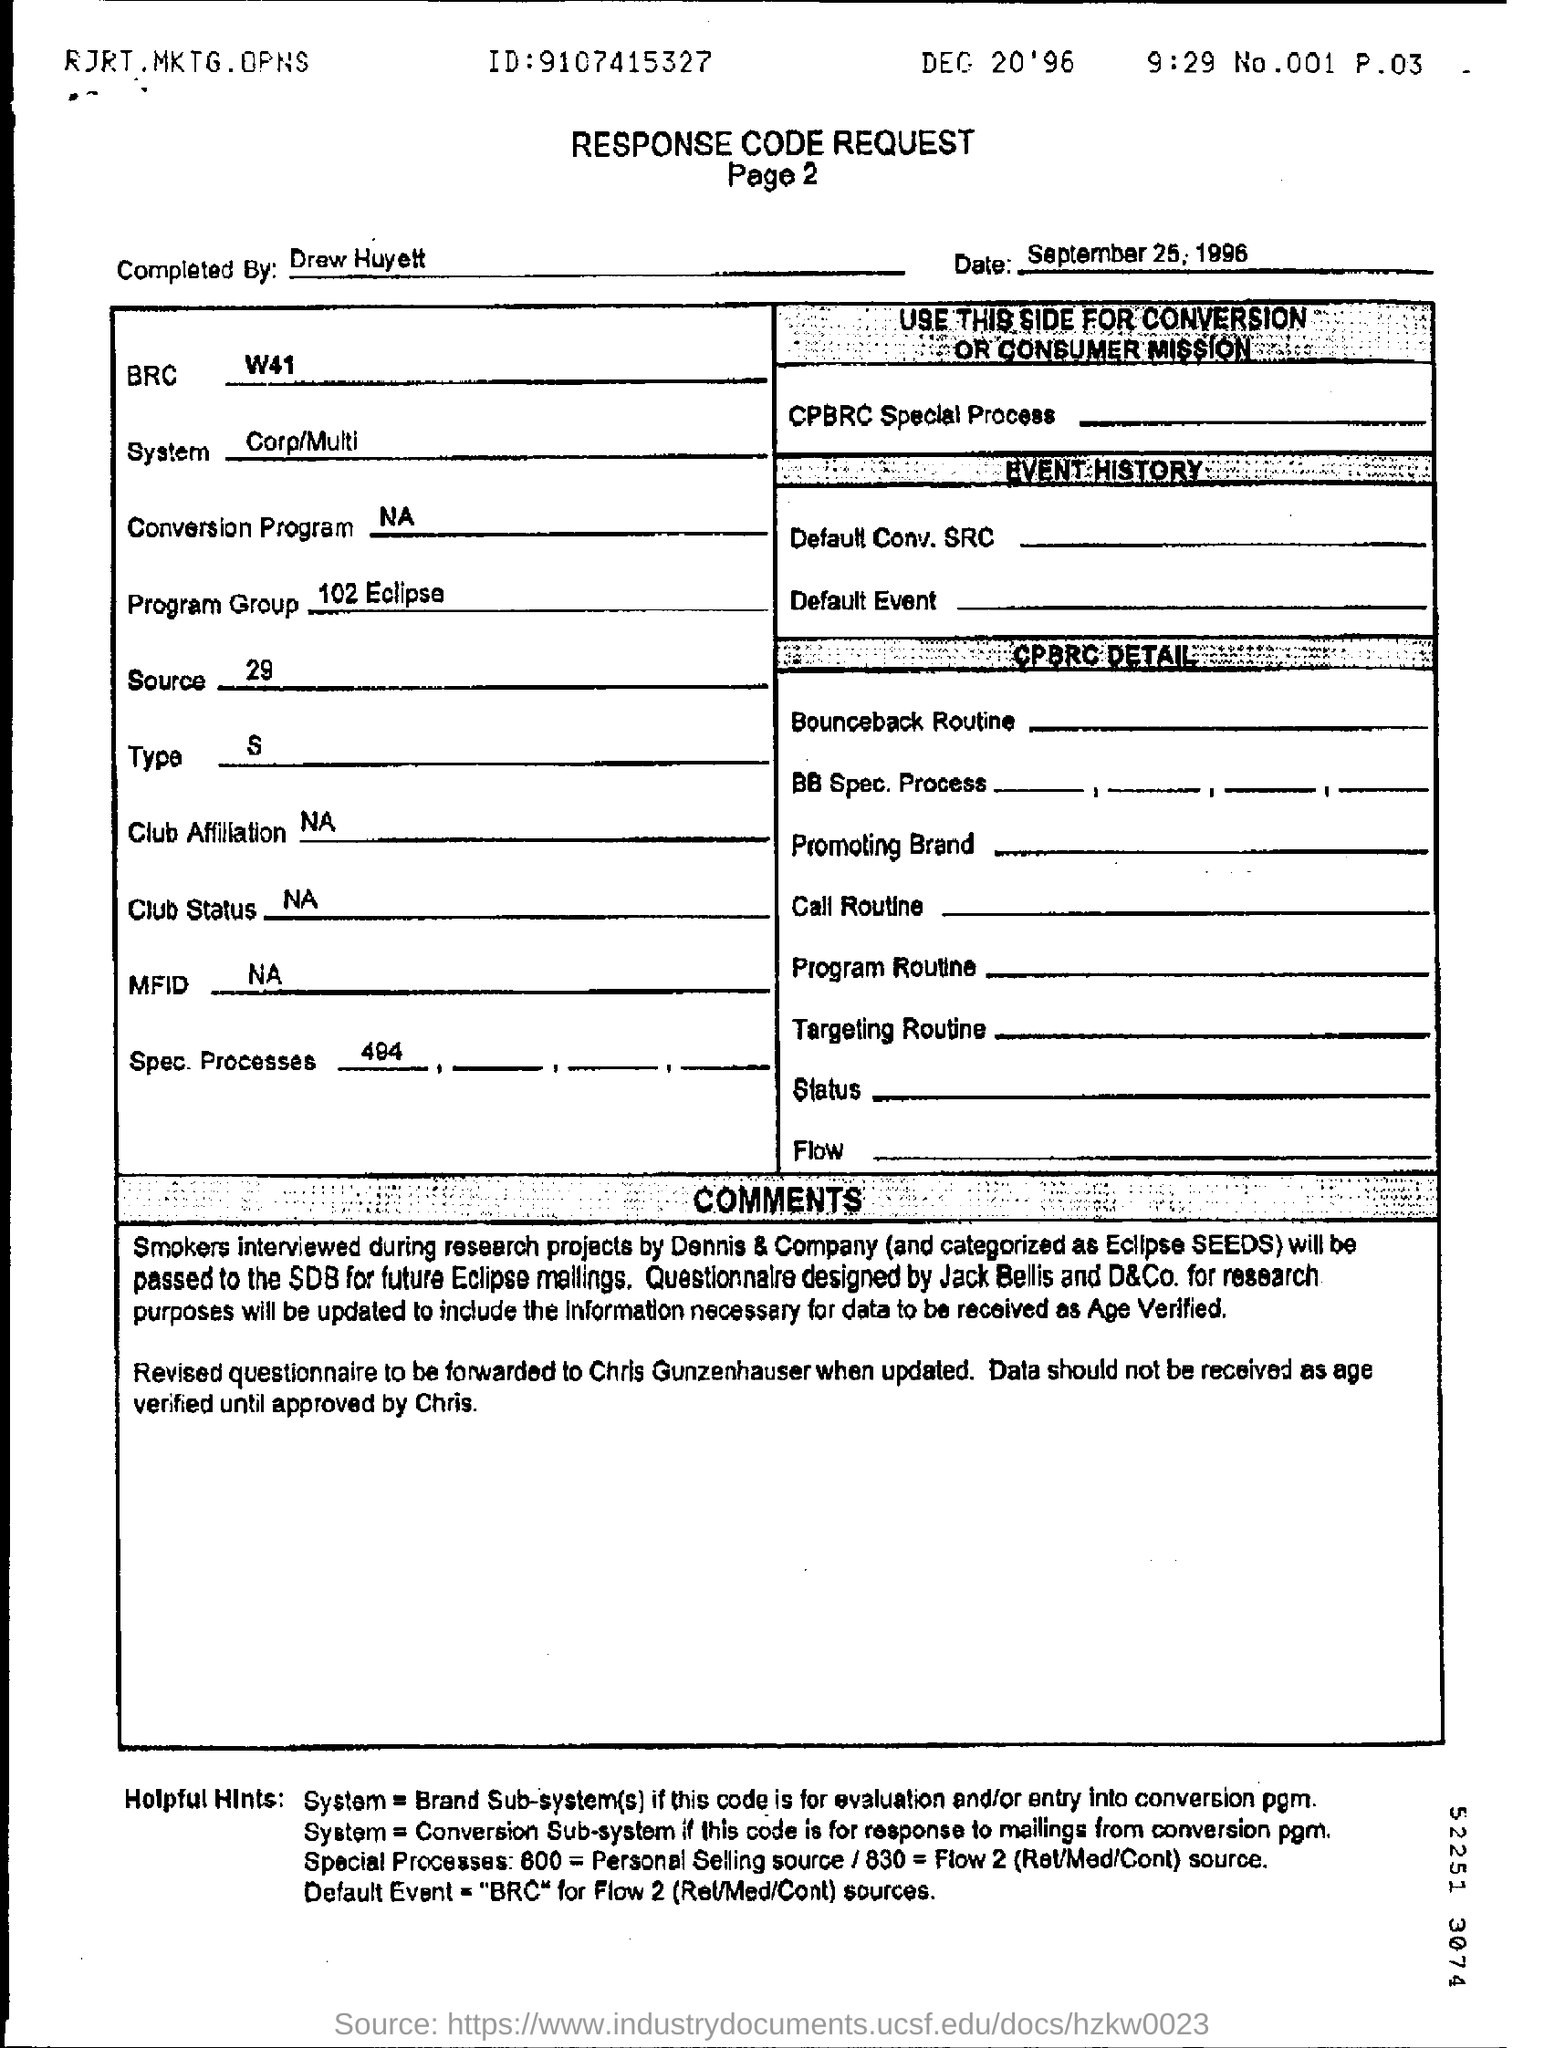What is the heading of the document?
Provide a succinct answer. Response Code Request. By whom was this document Completed?
Provide a succinct answer. Drew Huyett. What is the date mentioned just above the table?
Keep it short and to the point. September 25, 1996. 